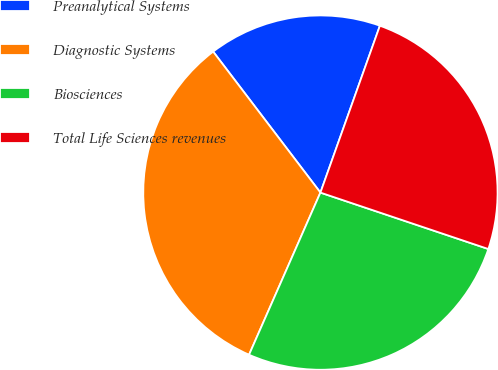Convert chart. <chart><loc_0><loc_0><loc_500><loc_500><pie_chart><fcel>Preanalytical Systems<fcel>Diagnostic Systems<fcel>Biosciences<fcel>Total Life Sciences revenues<nl><fcel>15.8%<fcel>33.05%<fcel>26.44%<fcel>24.71%<nl></chart> 